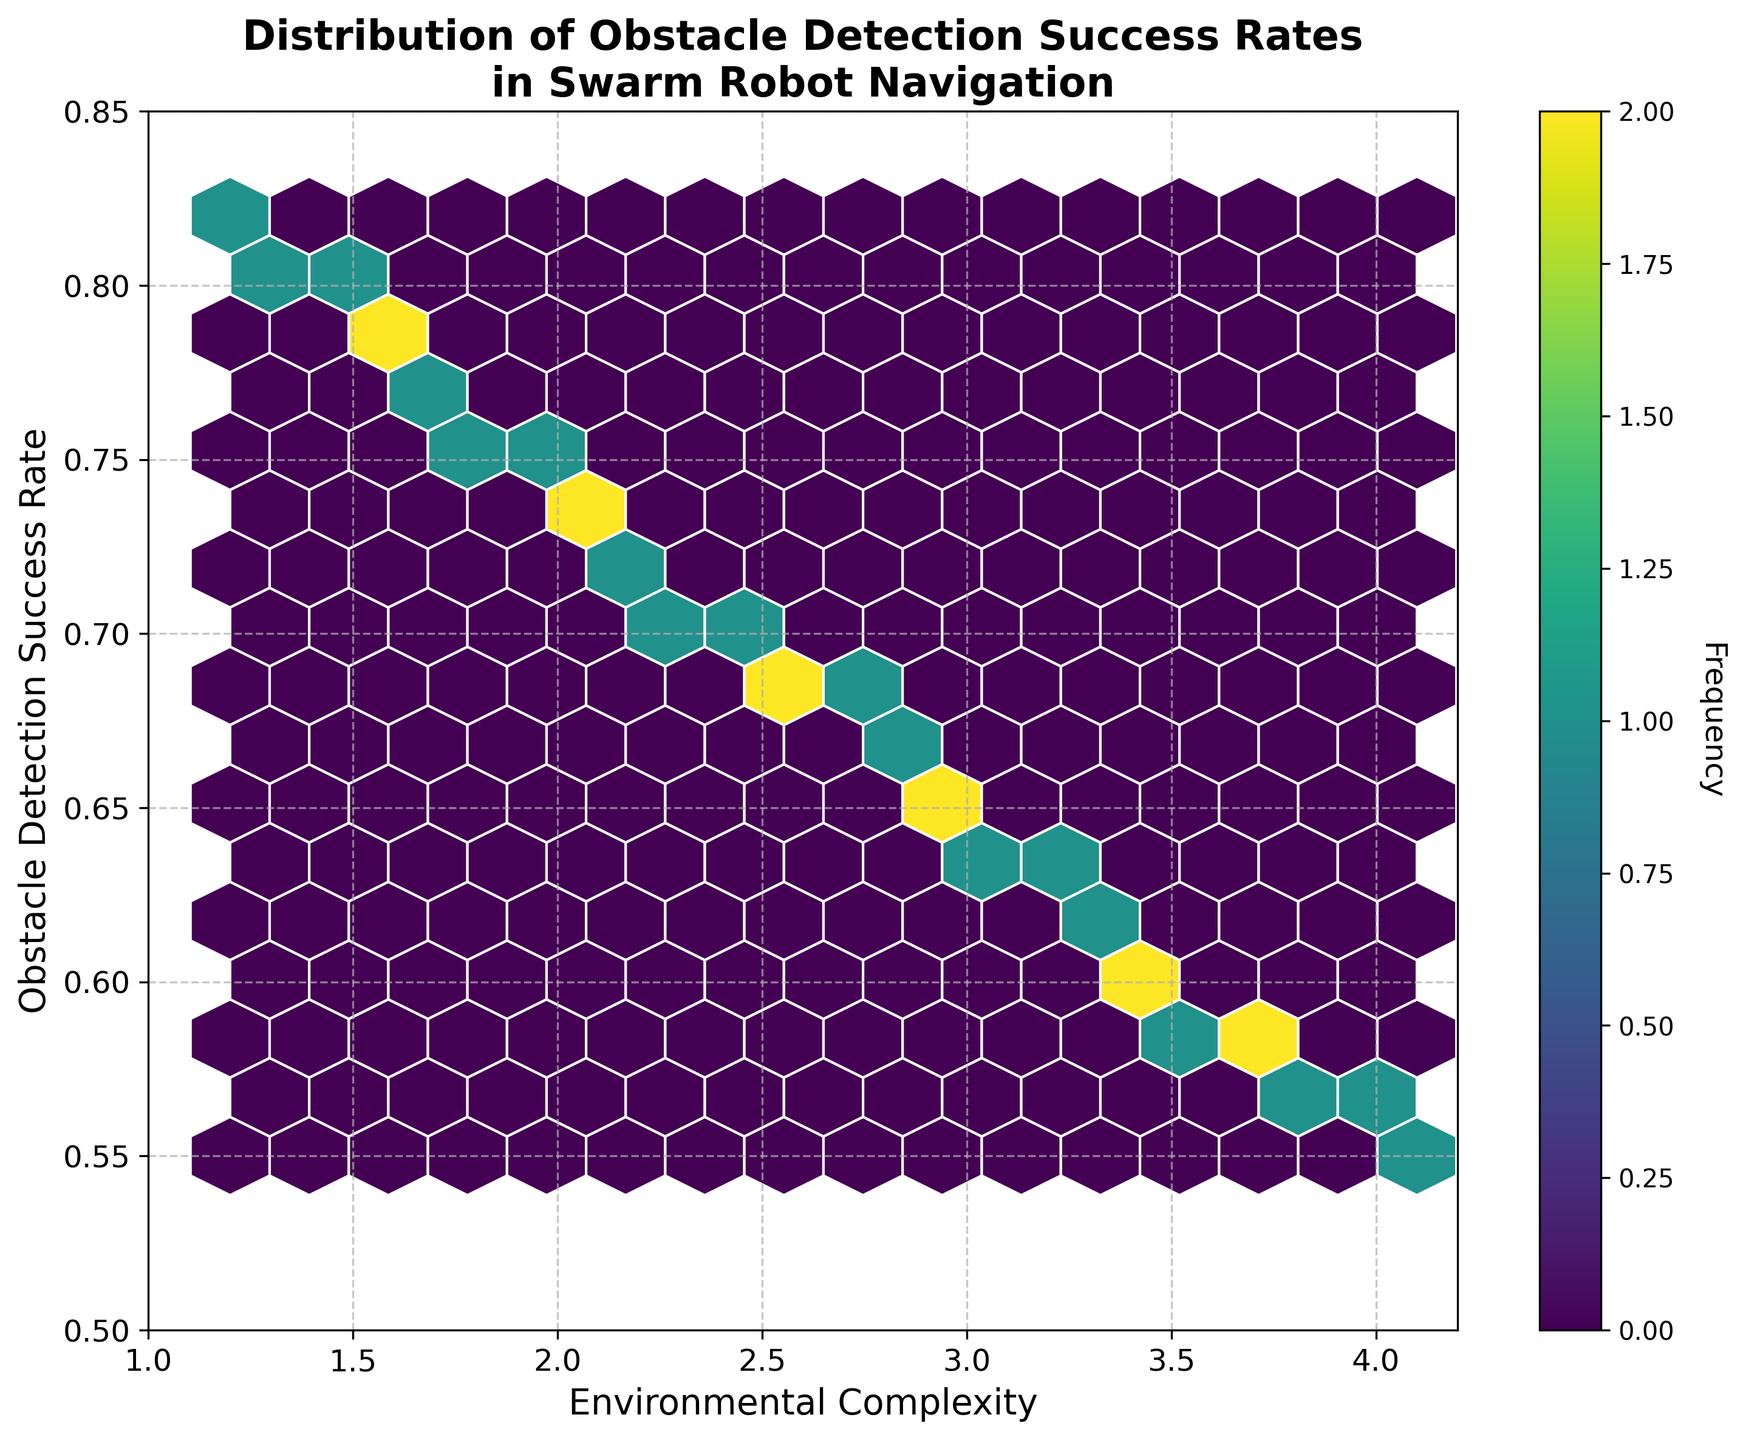What is the title of the plot? The title of the plot can be found at the top of the figure. It provides a brief description of what the plot represents.
Answer: Distribution of Obstacle Detection Success Rates in Swarm Robot Navigation What do the x and y axes represent in the plot? The x-axis and y-axis labels indicate the dimensions of the data being presented in the plot. The x-axis represents 'Environmental Complexity' and the y-axis represents 'Obstacle Detection Success Rate'.
Answer: Environmental Complexity, Obstacle Detection Success Rate What is the color scale used for in the hexbin plot? In a hexbin plot, the color scale represents the frequency of data points within each hexagonal bin. The color bar on the side of the plot helps interpret this information.
Answer: Frequency Where are the highest frequencies of data points located in the plot? To determine the highest frequencies, we look for the darkest hexagons in the plot. These represent the bins with the most data points.
Answer: Around Environmental Complexity values of 2.5-3.0 and Obstacle Detection Success Rates of 0.67-0.70 As Environmental Complexity increases, what trend do you observe in Obstacle Detection Success Rate? By examining the hexagons distributed along the x and y-axes, it's clear that as Environmental Complexity increases, the Obstacle Detection Success Rate generally decreases.
Answer: Decreases What is the Obstacle Detection Success Rate when Environmental Complexity is 1.5? By locating Environmental Complexity of 1.5 on the x-axis and checking the corresponding y-values, we see that the Obstacle Detection Success Rates are around 0.79.
Answer: 0.79 How are the data points distributed in terms of Environmental Complexity and Obstacle Detection Success Rate? We can observe that data points are more densely clustered at lower Environmental Complexity values with higher Obstacle Detection Success Rates and become sparser and lower as Environmental Complexity increases.
Answer: Densely clustered at lower complexities and higher success rates, sparser and lower as complexity increases Which values on the y-axis have the highest aggregation of data points when Environmental Complexity is around 3.0? Locate Environmental Complexity at around 3.0 on the x-axis and see the y-values that correspond to the most frequent hexagon colors. The Obstacle Detection Success Rate is mainly around 0.65.
Answer: 0.65 What is the overall trend exhibited in the hexbin plot? Observing the general direction that the hexagons are forming, the trend shows that as the Environmental Complexity increases (rightward on x-axis), the Obstacle Detection Success Rate decreases (downward on y-axis).
Answer: Increasing complexity leads to a decreasing success rate Compare the frequency distribution of data points between Environmental Complexity values of 1.2 and 4.1. By comparing hexagon color intensities at these x-axis values, it's evident that 1.2 has higher frequency bins (darker hexagons), while 4.1 has lower frequency bins (lighter hexagons).
Answer: More frequent at 1.2, less frequent at 4.1 